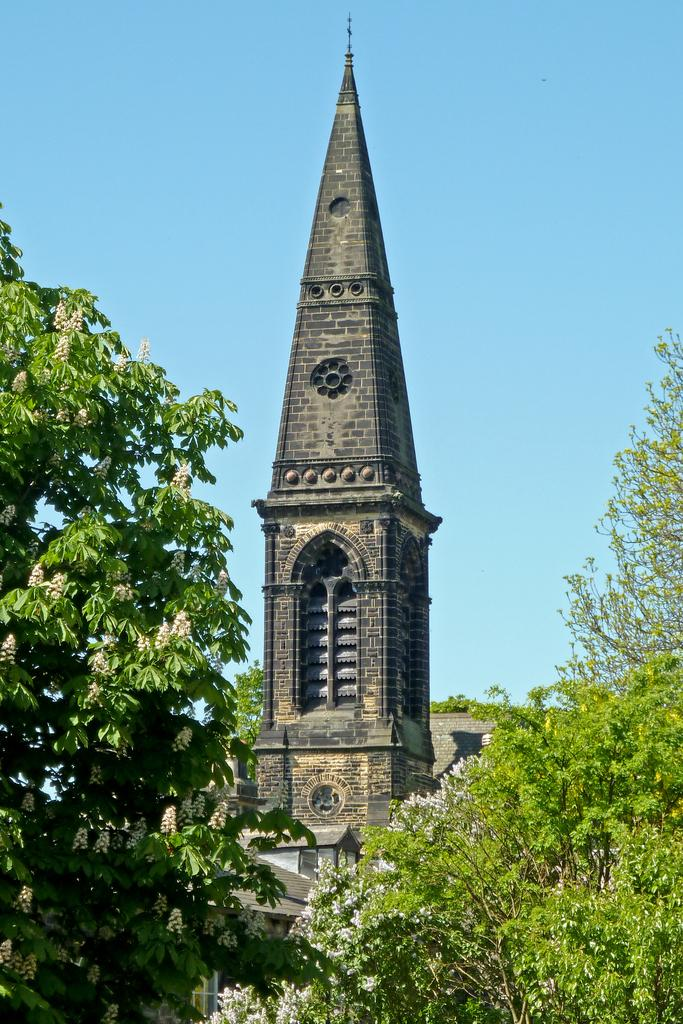What type of vegetation can be seen in the image? There are trees in the image. What structure is present in the image? There is a tower in the image. What is visible in the background of the image? The sky is visible in the image. Can you determine the time of day the image was taken? The image was likely taken during the day, as there is no indication of darkness or artificial lighting. What type of pin is holding the furniture together in the image? There is no furniture or pin present in the image. What kind of apparatus is used to climb the tower in the image? There is no apparatus or indication of climbing in the image; it simply shows a tower and trees. 